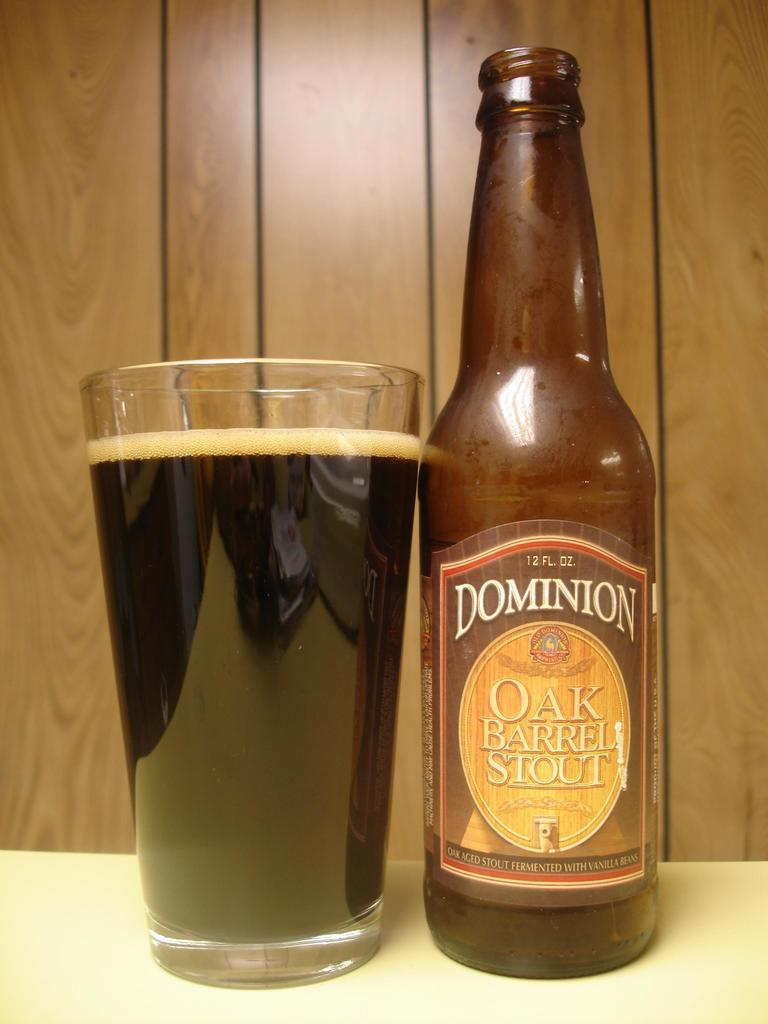Provide a one-sentence caption for the provided image. A glass full of Dominion Oak Barrel Stout with open bottle beside it. 